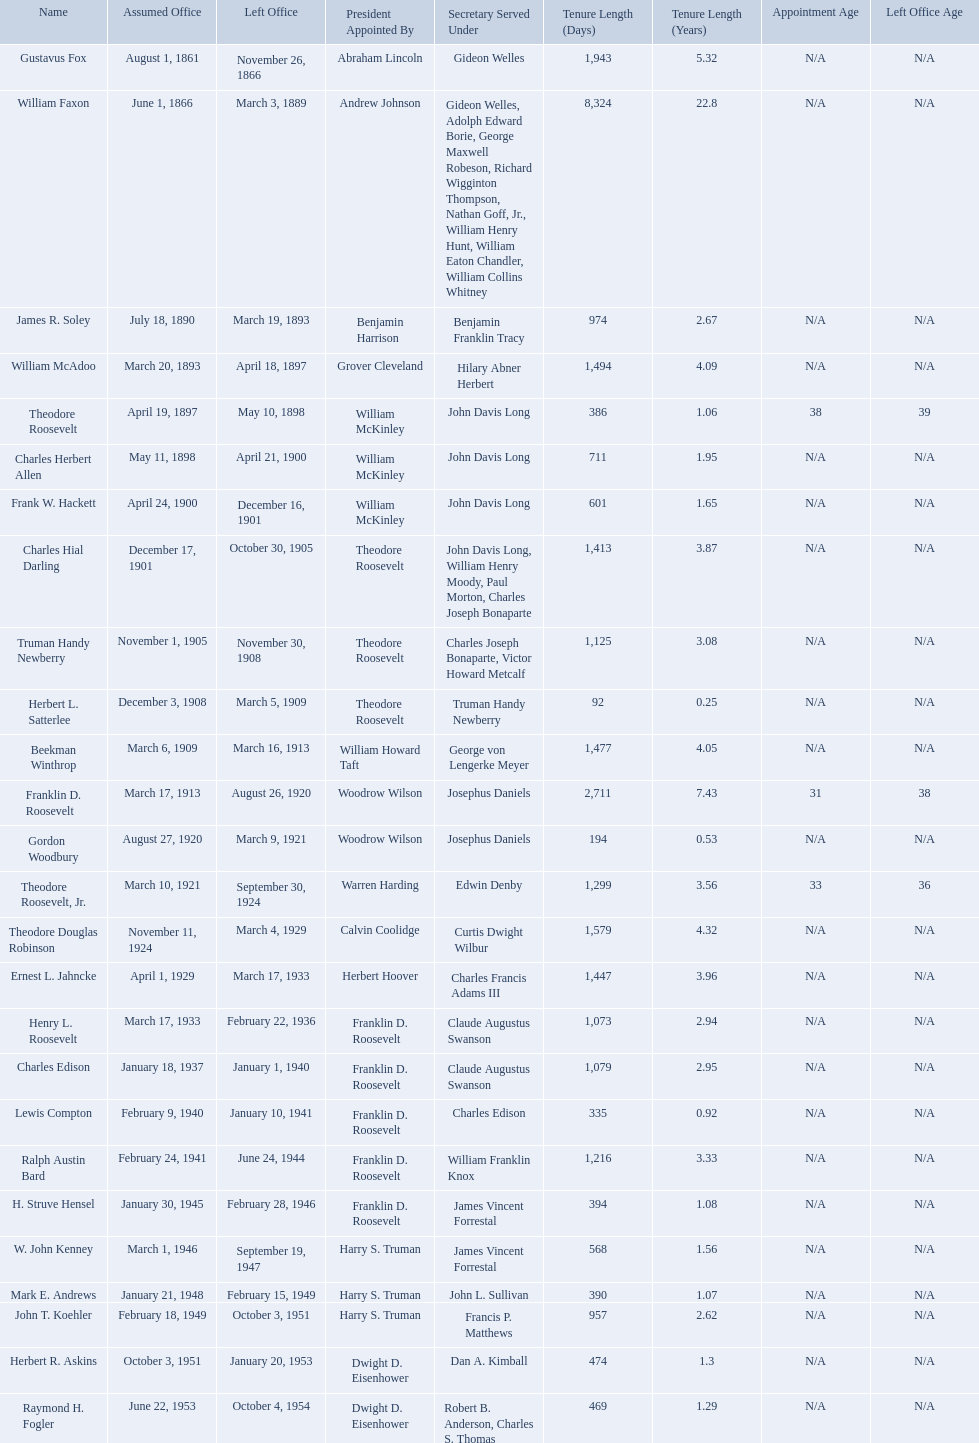Who were all the assistant secretary's of the navy? Gustavus Fox, William Faxon, James R. Soley, William McAdoo, Theodore Roosevelt, Charles Herbert Allen, Frank W. Hackett, Charles Hial Darling, Truman Handy Newberry, Herbert L. Satterlee, Beekman Winthrop, Franklin D. Roosevelt, Gordon Woodbury, Theodore Roosevelt, Jr., Theodore Douglas Robinson, Ernest L. Jahncke, Henry L. Roosevelt, Charles Edison, Lewis Compton, Ralph Austin Bard, H. Struve Hensel, W. John Kenney, Mark E. Andrews, John T. Koehler, Herbert R. Askins, Raymond H. Fogler. What are the various dates they left office in? November 26, 1866, March 3, 1889, March 19, 1893, April 18, 1897, May 10, 1898, April 21, 1900, December 16, 1901, October 30, 1905, November 30, 1908, March 5, 1909, March 16, 1913, August 26, 1920, March 9, 1921, September 30, 1924, March 4, 1929, March 17, 1933, February 22, 1936, January 1, 1940, January 10, 1941, June 24, 1944, February 28, 1946, September 19, 1947, February 15, 1949, October 3, 1951, January 20, 1953, October 4, 1954. Of these dates, which was the date raymond h. fogler left office in? October 4, 1954. What are all the names? Gustavus Fox, William Faxon, James R. Soley, William McAdoo, Theodore Roosevelt, Charles Herbert Allen, Frank W. Hackett, Charles Hial Darling, Truman Handy Newberry, Herbert L. Satterlee, Beekman Winthrop, Franklin D. Roosevelt, Gordon Woodbury, Theodore Roosevelt, Jr., Theodore Douglas Robinson, Ernest L. Jahncke, Henry L. Roosevelt, Charles Edison, Lewis Compton, Ralph Austin Bard, H. Struve Hensel, W. John Kenney, Mark E. Andrews, John T. Koehler, Herbert R. Askins, Raymond H. Fogler. When did they leave office? November 26, 1866, March 3, 1889, March 19, 1893, April 18, 1897, May 10, 1898, April 21, 1900, December 16, 1901, October 30, 1905, November 30, 1908, March 5, 1909, March 16, 1913, August 26, 1920, March 9, 1921, September 30, 1924, March 4, 1929, March 17, 1933, February 22, 1936, January 1, 1940, January 10, 1941, June 24, 1944, February 28, 1946, September 19, 1947, February 15, 1949, October 3, 1951, January 20, 1953, October 4, 1954. And when did raymond h. fogler leave? October 4, 1954. 